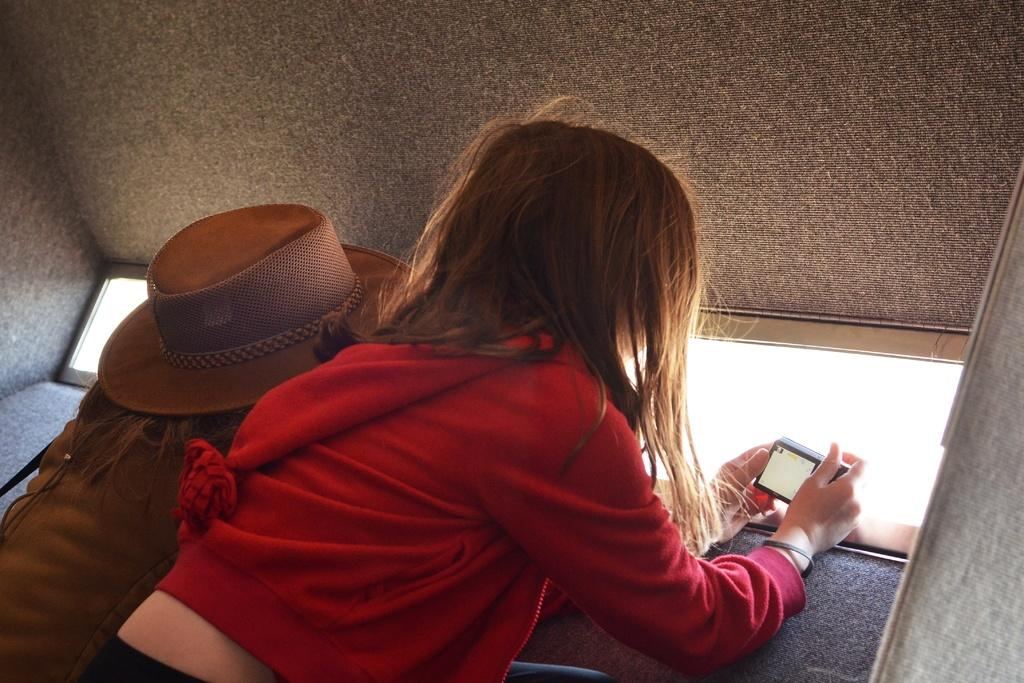Who is the main subject in the image? There is a girl in the image. What is the girl holding in the image? The girl is holding a camera. Can you describe the other person in the image? The other person is wearing a hat. What advice does the girl give to the person wearing the hat in the image? There is no indication in the image that the girl is giving advice to the person wearing the hat. 